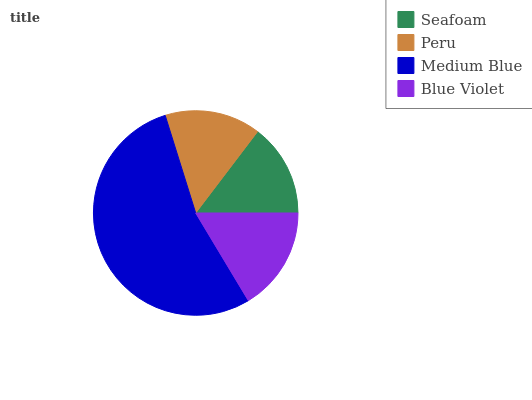Is Seafoam the minimum?
Answer yes or no. Yes. Is Medium Blue the maximum?
Answer yes or no. Yes. Is Peru the minimum?
Answer yes or no. No. Is Peru the maximum?
Answer yes or no. No. Is Peru greater than Seafoam?
Answer yes or no. Yes. Is Seafoam less than Peru?
Answer yes or no. Yes. Is Seafoam greater than Peru?
Answer yes or no. No. Is Peru less than Seafoam?
Answer yes or no. No. Is Blue Violet the high median?
Answer yes or no. Yes. Is Peru the low median?
Answer yes or no. Yes. Is Seafoam the high median?
Answer yes or no. No. Is Blue Violet the low median?
Answer yes or no. No. 